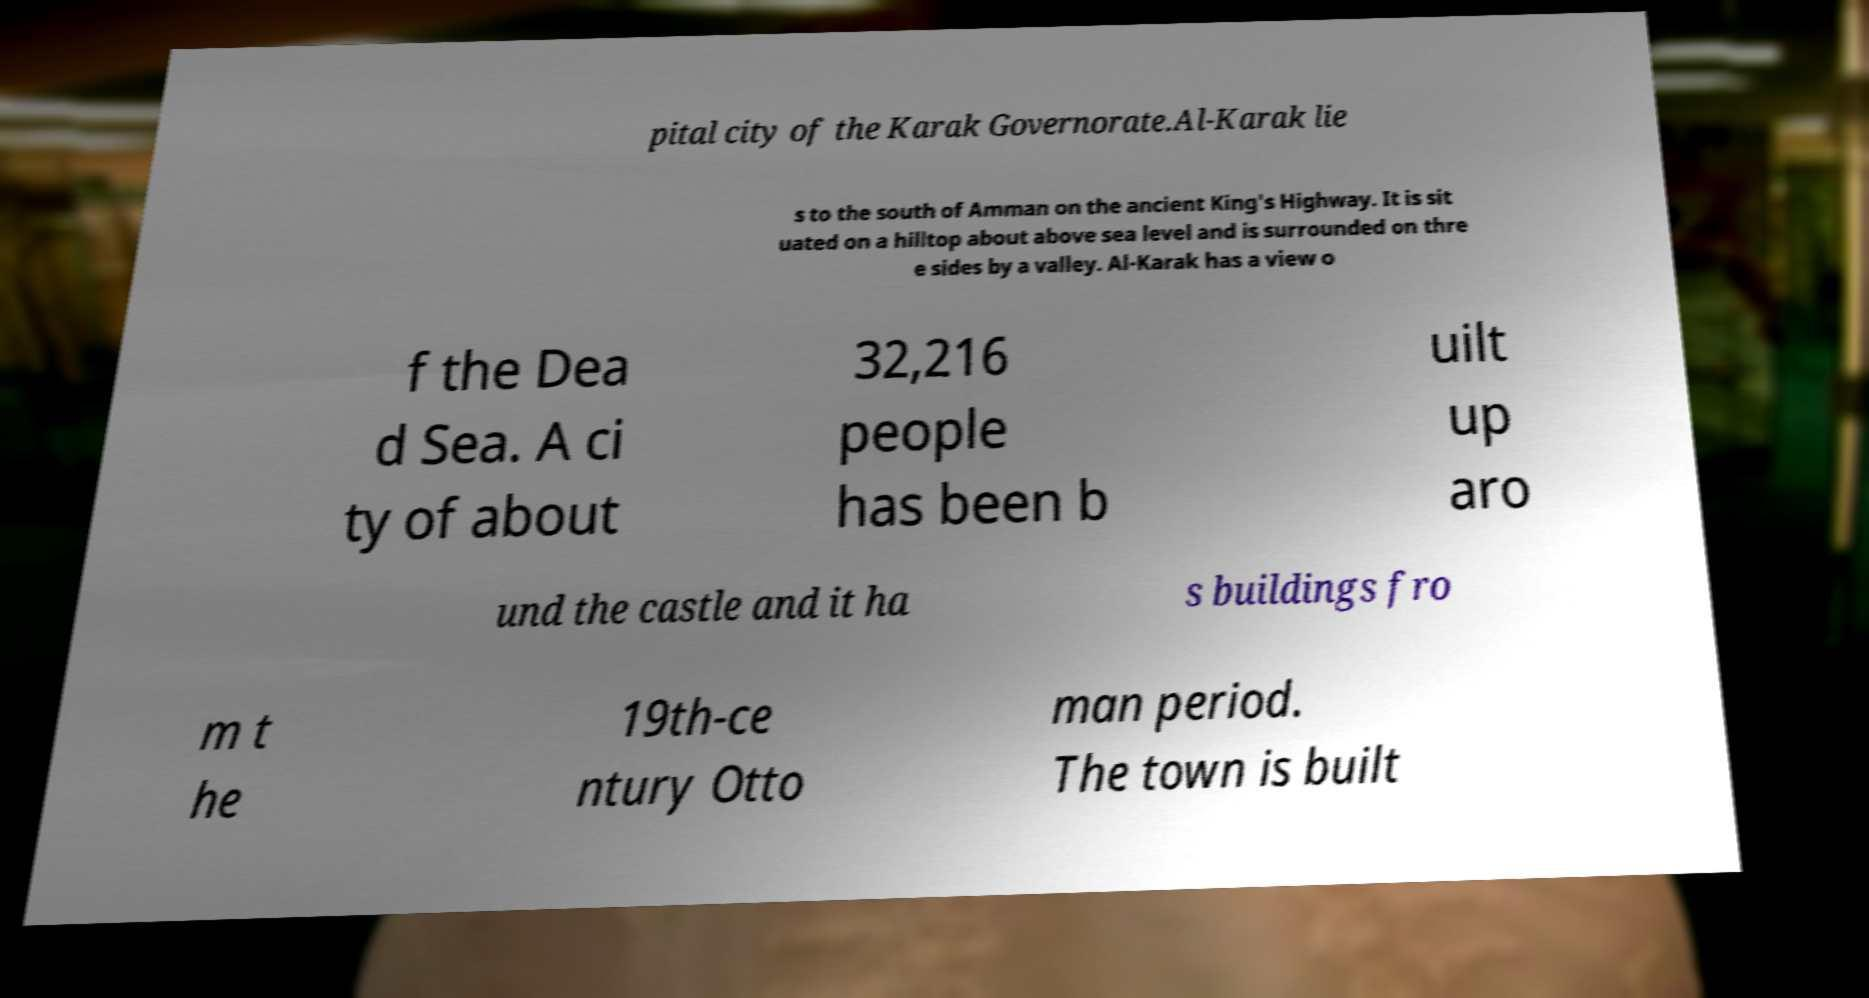I need the written content from this picture converted into text. Can you do that? pital city of the Karak Governorate.Al-Karak lie s to the south of Amman on the ancient King's Highway. It is sit uated on a hilltop about above sea level and is surrounded on thre e sides by a valley. Al-Karak has a view o f the Dea d Sea. A ci ty of about 32,216 people has been b uilt up aro und the castle and it ha s buildings fro m t he 19th-ce ntury Otto man period. The town is built 